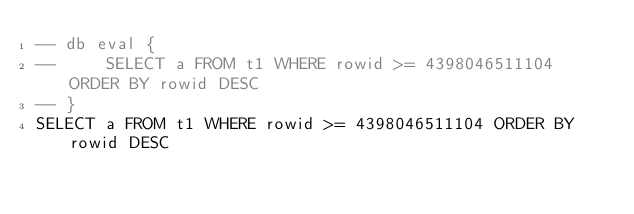Convert code to text. <code><loc_0><loc_0><loc_500><loc_500><_SQL_>-- db eval {
--     SELECT a FROM t1 WHERE rowid >= 4398046511104 ORDER BY rowid DESC
-- }
SELECT a FROM t1 WHERE rowid >= 4398046511104 ORDER BY rowid DESC</code> 